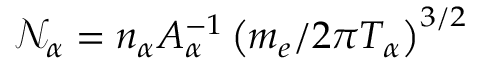Convert formula to latex. <formula><loc_0><loc_0><loc_500><loc_500>\mathcal { N } _ { \alpha } = n _ { \alpha } A _ { \alpha } ^ { - 1 } \left ( m _ { e } / 2 \pi T _ { \alpha } \right ) ^ { 3 / 2 }</formula> 